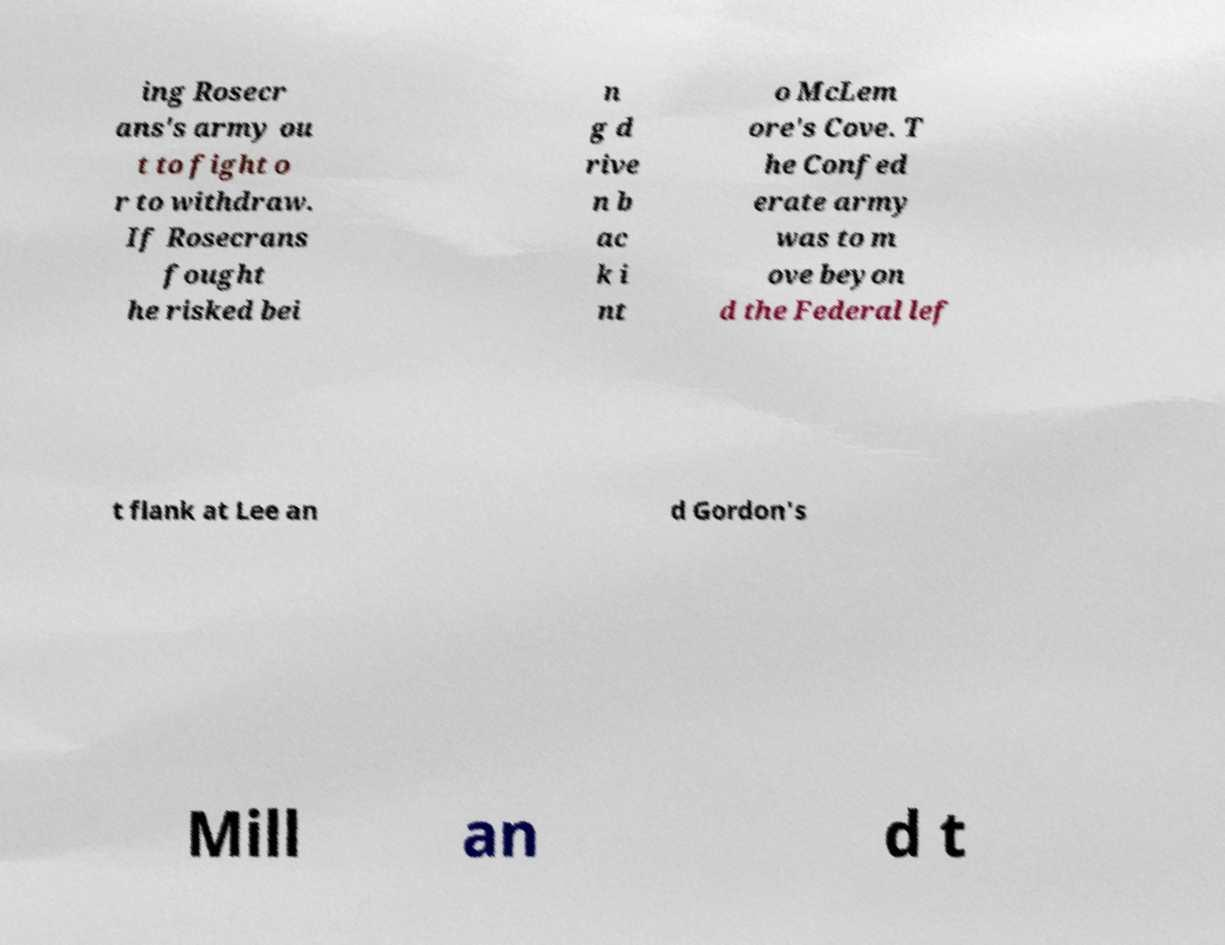Please identify and transcribe the text found in this image. ing Rosecr ans's army ou t to fight o r to withdraw. If Rosecrans fought he risked bei n g d rive n b ac k i nt o McLem ore's Cove. T he Confed erate army was to m ove beyon d the Federal lef t flank at Lee an d Gordon's Mill an d t 